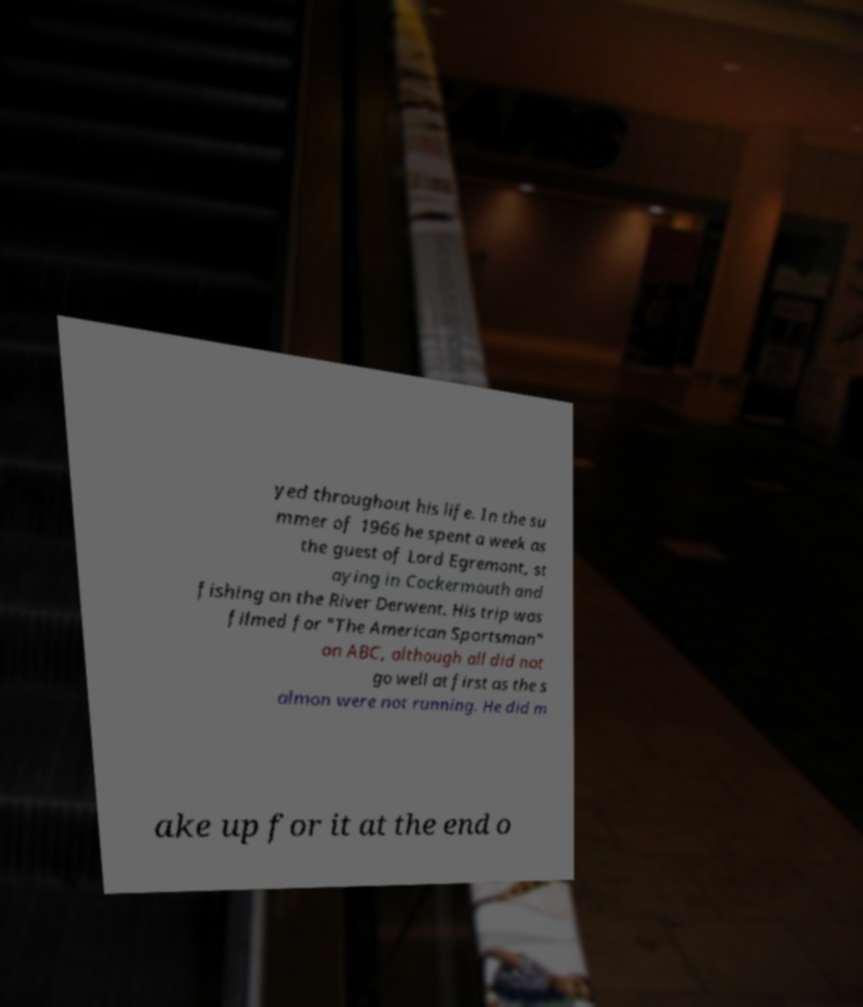Can you read and provide the text displayed in the image?This photo seems to have some interesting text. Can you extract and type it out for me? yed throughout his life. In the su mmer of 1966 he spent a week as the guest of Lord Egremont, st aying in Cockermouth and fishing on the River Derwent. His trip was filmed for "The American Sportsman" on ABC, although all did not go well at first as the s almon were not running. He did m ake up for it at the end o 